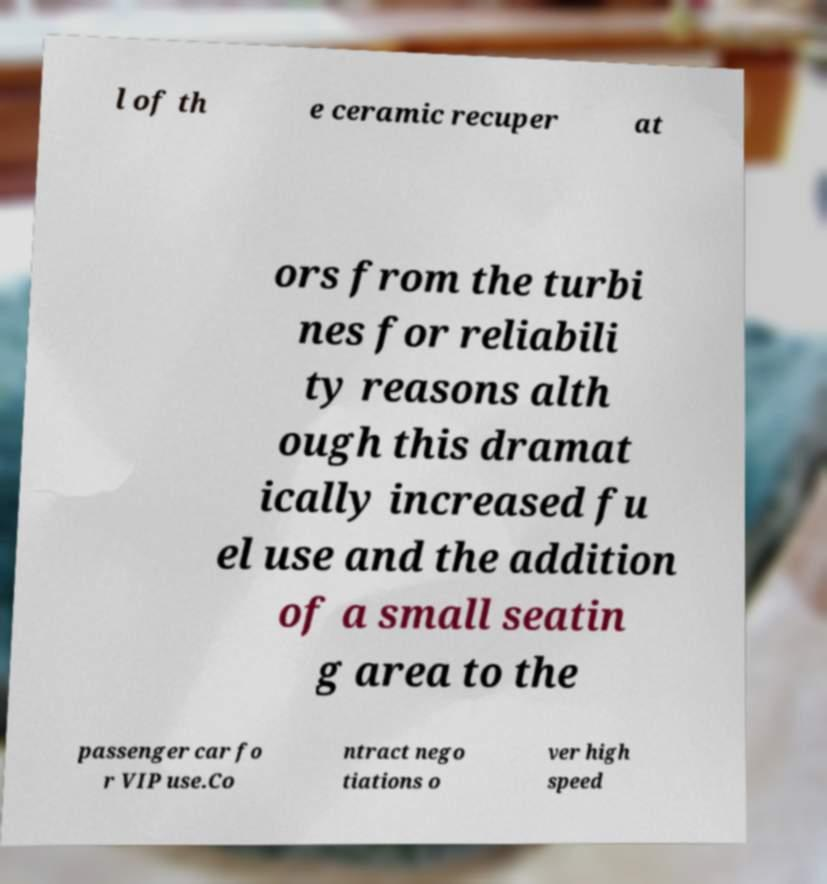There's text embedded in this image that I need extracted. Can you transcribe it verbatim? l of th e ceramic recuper at ors from the turbi nes for reliabili ty reasons alth ough this dramat ically increased fu el use and the addition of a small seatin g area to the passenger car fo r VIP use.Co ntract nego tiations o ver high speed 